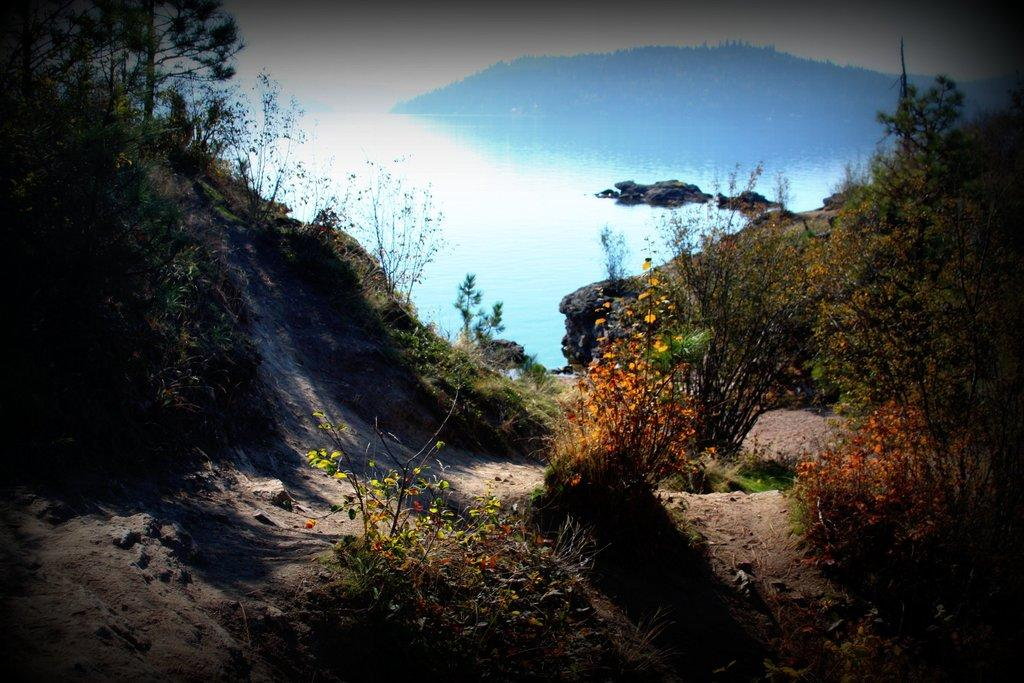What type of vegetation can be seen on the right side of the image? There are flowers on the right side of the image. What type of vegetation can be seen on the left side of the image? There are trees on the left side of the image. Are there any trees visible on both sides of the image? Yes, there are trees on both the left and right sides of the image. What can be seen in the background of the image? The ocean is visible in the background of the image. Can you tell me how many celery stalks are in the image? There is no celery present in the image. Is there a train visible in the image? No, there is no train present in the image. 